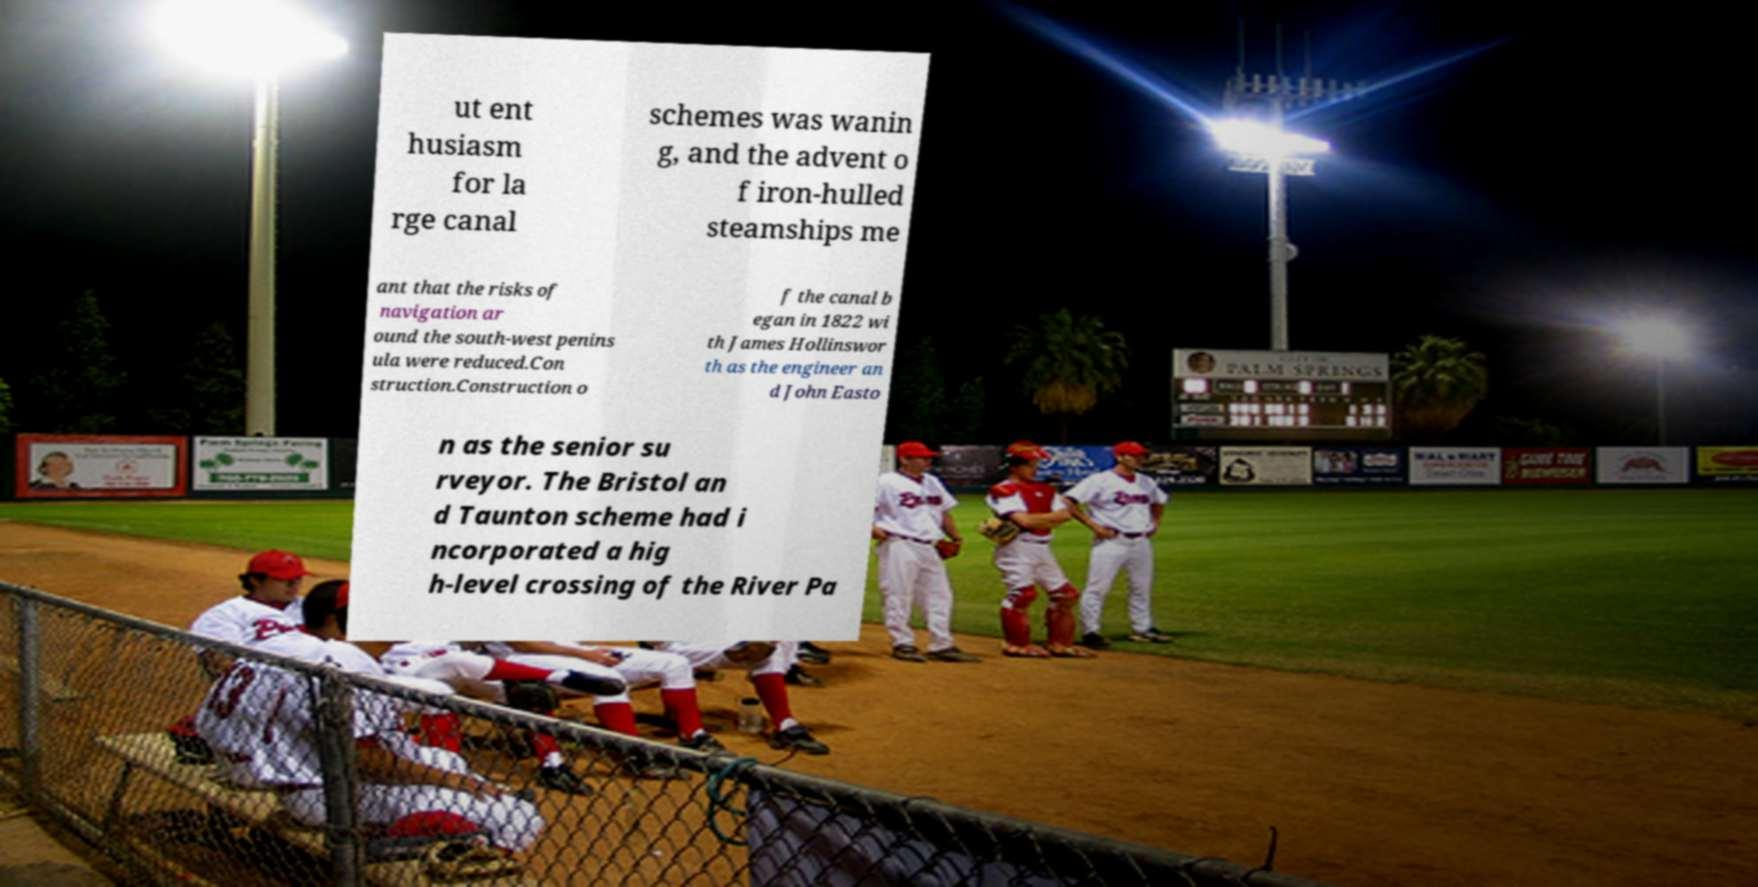Can you read and provide the text displayed in the image?This photo seems to have some interesting text. Can you extract and type it out for me? ut ent husiasm for la rge canal schemes was wanin g, and the advent o f iron-hulled steamships me ant that the risks of navigation ar ound the south-west penins ula were reduced.Con struction.Construction o f the canal b egan in 1822 wi th James Hollinswor th as the engineer an d John Easto n as the senior su rveyor. The Bristol an d Taunton scheme had i ncorporated a hig h-level crossing of the River Pa 